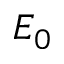Convert formula to latex. <formula><loc_0><loc_0><loc_500><loc_500>E _ { 0 }</formula> 